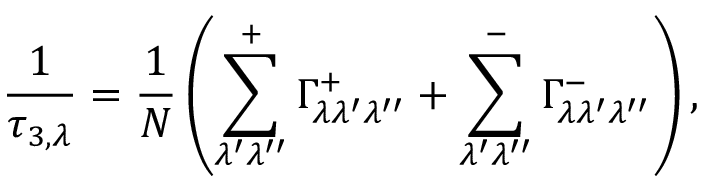Convert formula to latex. <formula><loc_0><loc_0><loc_500><loc_500>\frac { 1 } { \tau _ { 3 , \lambda } } = \frac { 1 } { N } \left ( \sum _ { \lambda ^ { \prime } \lambda ^ { \prime \prime } } ^ { + } { \Gamma _ { \lambda \lambda ^ { \prime } \lambda ^ { \prime \prime } } ^ { + } } + \sum _ { \lambda ^ { \prime } \lambda ^ { \prime \prime } } ^ { - } { \Gamma _ { \lambda \lambda ^ { \prime } \lambda ^ { \prime \prime } } ^ { - } } \right ) ,</formula> 